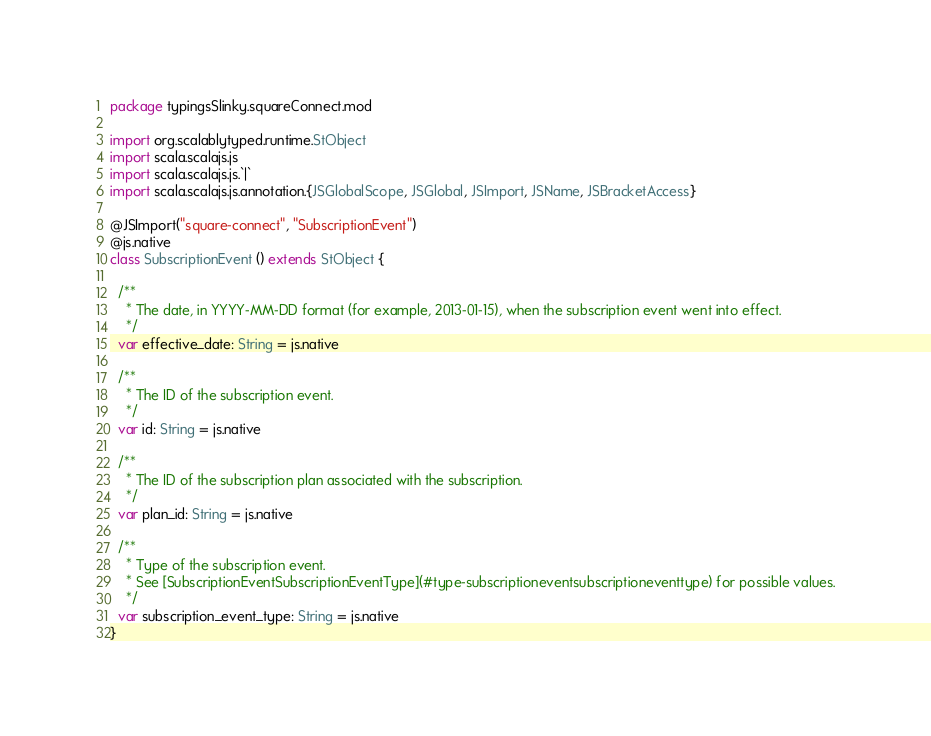<code> <loc_0><loc_0><loc_500><loc_500><_Scala_>package typingsSlinky.squareConnect.mod

import org.scalablytyped.runtime.StObject
import scala.scalajs.js
import scala.scalajs.js.`|`
import scala.scalajs.js.annotation.{JSGlobalScope, JSGlobal, JSImport, JSName, JSBracketAccess}

@JSImport("square-connect", "SubscriptionEvent")
@js.native
class SubscriptionEvent () extends StObject {
  
  /**
    * The date, in YYYY-MM-DD format (for example, 2013-01-15), when the subscription event went into effect.
    */
  var effective_date: String = js.native
  
  /**
    * The ID of the subscription event.
    */
  var id: String = js.native
  
  /**
    * The ID of the subscription plan associated with the subscription.
    */
  var plan_id: String = js.native
  
  /**
    * Type of the subscription event.
    * See [SubscriptionEventSubscriptionEventType](#type-subscriptioneventsubscriptioneventtype) for possible values.
    */
  var subscription_event_type: String = js.native
}
</code> 